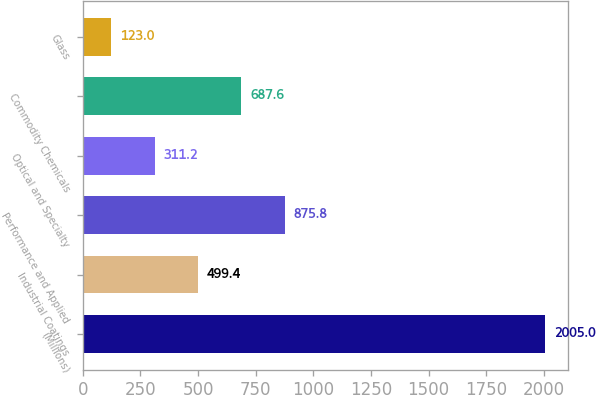Convert chart to OTSL. <chart><loc_0><loc_0><loc_500><loc_500><bar_chart><fcel>(Millions)<fcel>Industrial Coatings<fcel>Performance and Applied<fcel>Optical and Specialty<fcel>Commodity Chemicals<fcel>Glass<nl><fcel>2005<fcel>499.4<fcel>875.8<fcel>311.2<fcel>687.6<fcel>123<nl></chart> 